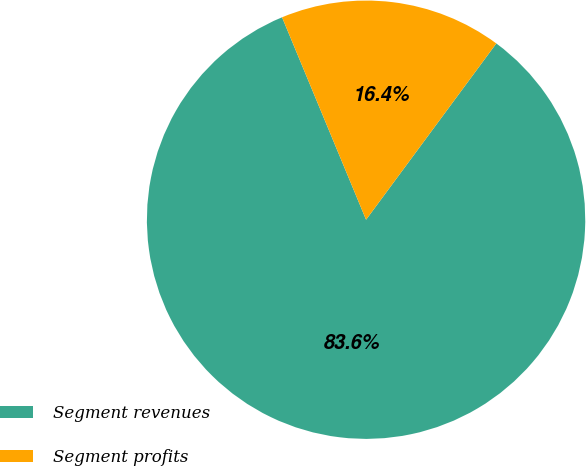<chart> <loc_0><loc_0><loc_500><loc_500><pie_chart><fcel>Segment revenues<fcel>Segment profits<nl><fcel>83.61%<fcel>16.39%<nl></chart> 